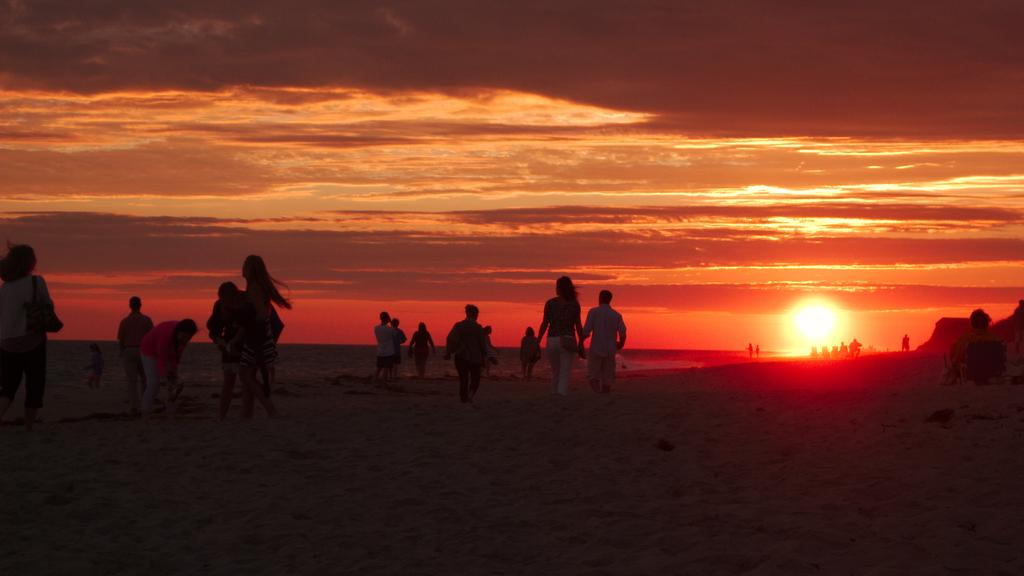What is the main setting of the image? The main setting of the image is the sea shore. What can be seen in the background of the image? The sky is visible in the background of the image. What celestial body is present in the sky? The sun is present in the sky. What other atmospheric features can be seen in the sky? Clouds are visible in the sky. What is the color of the sky in the image? The sky has a red color in the image. What type of parcel is being delivered to the meeting on the sea shore? There is no meeting or parcel present in the image; it features many people on the sea shore with a red sky. 